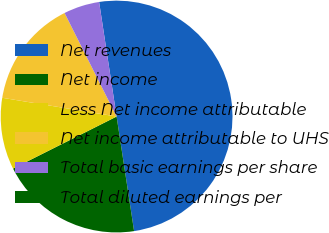Convert chart. <chart><loc_0><loc_0><loc_500><loc_500><pie_chart><fcel>Net revenues<fcel>Net income<fcel>Less Net income attributable<fcel>Net income attributable to UHS<fcel>Total basic earnings per share<fcel>Total diluted earnings per<nl><fcel>50.0%<fcel>20.0%<fcel>10.0%<fcel>15.0%<fcel>5.0%<fcel>0.0%<nl></chart> 